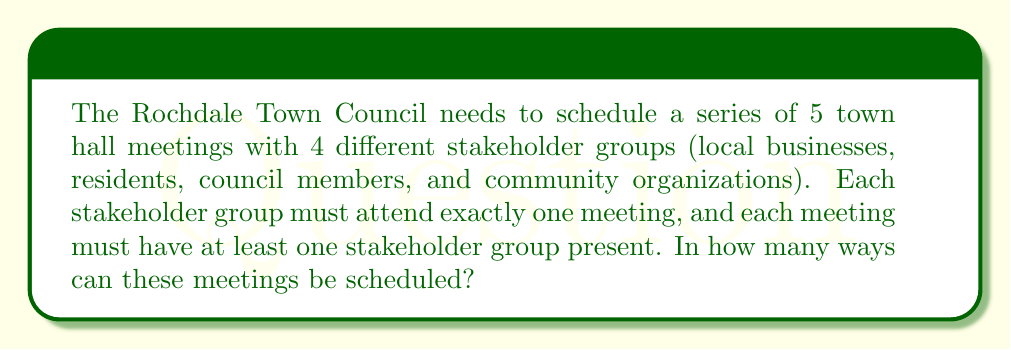Help me with this question. Let's approach this step-by-step using the principle of inclusion-exclusion:

1) First, consider the total number of ways to distribute 4 stakeholder groups among 5 meetings without restrictions:
   $5^4 = 625$ (each group has 5 choices)

2) However, we need to subtract the cases where one or more meetings have no stakeholders:

   a) Number of ways with at least one empty meeting:
      $\binom{5}{1} \cdot 4^4 = 5 \cdot 256 = 1280$

   b) Number of ways with at least two empty meetings:
      $\binom{5}{2} \cdot 3^4 = 10 \cdot 81 = 810$

   c) Number of ways with at least three empty meetings:
      $\binom{5}{3} \cdot 2^4 = 10 \cdot 16 = 160$

   d) Number of ways with at least four empty meetings:
      $\binom{5}{4} \cdot 1^4 = 5 \cdot 1 = 5$

3) Apply the principle of inclusion-exclusion:

   $$\text{Total} = 5^4 - \binom{5}{1}4^4 + \binom{5}{2}3^4 - \binom{5}{3}2^4 + \binom{5}{4}1^4$$

4) Substitute the values:

   $$\text{Total} = 625 - 1280 + 810 - 160 + 5 = 0$$

5) The result is 0, which means there are no valid schedules under these constraints.

6) This makes sense because with 5 meetings and 4 stakeholder groups, at least one meeting will always be empty if each group attends exactly one meeting.
Answer: 0 